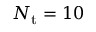Convert formula to latex. <formula><loc_0><loc_0><loc_500><loc_500>N _ { t } = 1 0</formula> 